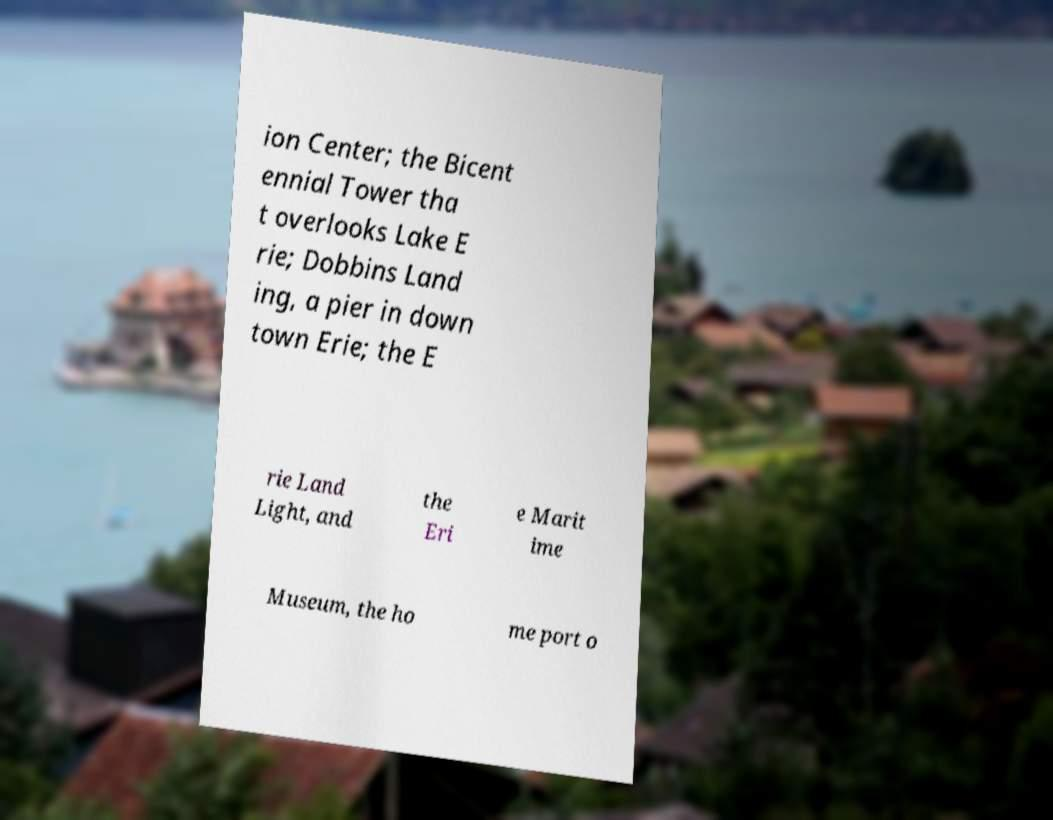Could you extract and type out the text from this image? ion Center; the Bicent ennial Tower tha t overlooks Lake E rie; Dobbins Land ing, a pier in down town Erie; the E rie Land Light, and the Eri e Marit ime Museum, the ho me port o 